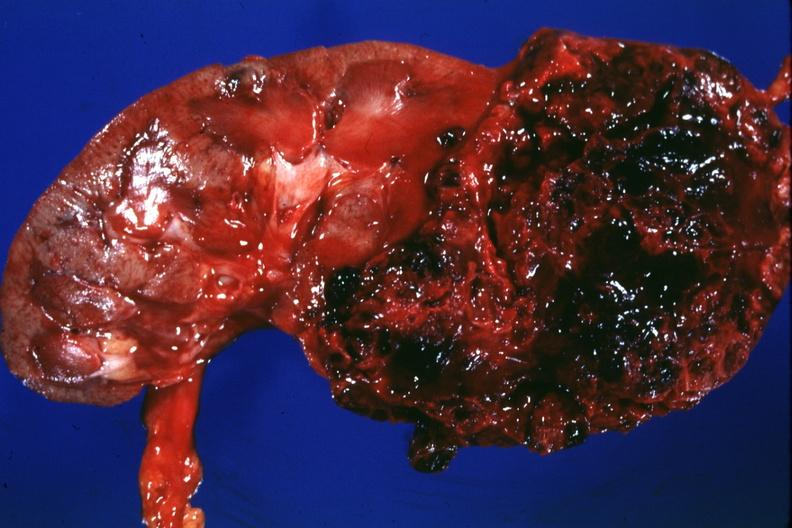s kidney present?
Answer the question using a single word or phrase. Yes 